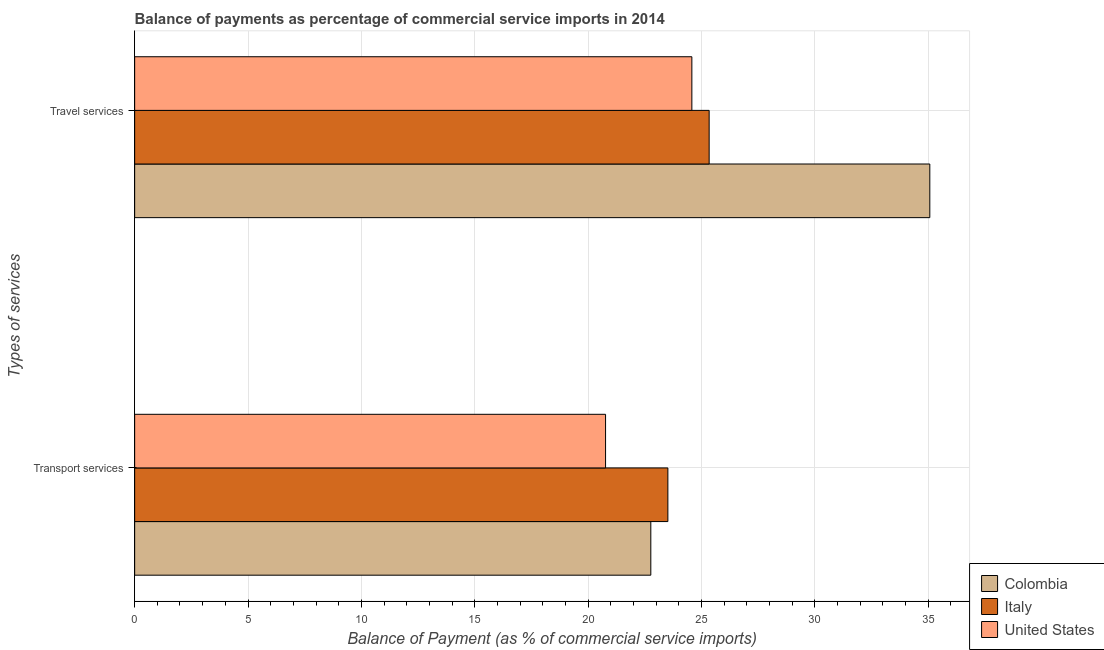How many different coloured bars are there?
Your response must be concise. 3. Are the number of bars on each tick of the Y-axis equal?
Give a very brief answer. Yes. What is the label of the 1st group of bars from the top?
Your answer should be very brief. Travel services. What is the balance of payments of transport services in United States?
Ensure brevity in your answer.  20.77. Across all countries, what is the maximum balance of payments of transport services?
Your answer should be very brief. 23.52. Across all countries, what is the minimum balance of payments of travel services?
Offer a terse response. 24.58. In which country was the balance of payments of travel services maximum?
Offer a very short reply. Colombia. What is the total balance of payments of travel services in the graph?
Your answer should be compact. 85. What is the difference between the balance of payments of transport services in United States and that in Colombia?
Offer a terse response. -2. What is the difference between the balance of payments of travel services in Italy and the balance of payments of transport services in United States?
Provide a succinct answer. 4.57. What is the average balance of payments of transport services per country?
Keep it short and to the point. 22.35. What is the difference between the balance of payments of travel services and balance of payments of transport services in Italy?
Provide a succinct answer. 1.82. What is the ratio of the balance of payments of transport services in United States to that in Italy?
Offer a terse response. 0.88. Is the balance of payments of transport services in United States less than that in Colombia?
Provide a succinct answer. Yes. What does the 1st bar from the top in Transport services represents?
Your answer should be compact. United States. What does the 3rd bar from the bottom in Transport services represents?
Your answer should be compact. United States. How many bars are there?
Offer a terse response. 6. Are all the bars in the graph horizontal?
Your answer should be compact. Yes. What is the difference between two consecutive major ticks on the X-axis?
Keep it short and to the point. 5. Does the graph contain grids?
Ensure brevity in your answer.  Yes. How are the legend labels stacked?
Provide a short and direct response. Vertical. What is the title of the graph?
Offer a terse response. Balance of payments as percentage of commercial service imports in 2014. Does "Nepal" appear as one of the legend labels in the graph?
Give a very brief answer. No. What is the label or title of the X-axis?
Your response must be concise. Balance of Payment (as % of commercial service imports). What is the label or title of the Y-axis?
Make the answer very short. Types of services. What is the Balance of Payment (as % of commercial service imports) in Colombia in Transport services?
Offer a terse response. 22.77. What is the Balance of Payment (as % of commercial service imports) in Italy in Transport services?
Make the answer very short. 23.52. What is the Balance of Payment (as % of commercial service imports) of United States in Transport services?
Ensure brevity in your answer.  20.77. What is the Balance of Payment (as % of commercial service imports) of Colombia in Travel services?
Your answer should be compact. 35.08. What is the Balance of Payment (as % of commercial service imports) of Italy in Travel services?
Provide a succinct answer. 25.34. What is the Balance of Payment (as % of commercial service imports) in United States in Travel services?
Make the answer very short. 24.58. Across all Types of services, what is the maximum Balance of Payment (as % of commercial service imports) in Colombia?
Offer a terse response. 35.08. Across all Types of services, what is the maximum Balance of Payment (as % of commercial service imports) in Italy?
Provide a succinct answer. 25.34. Across all Types of services, what is the maximum Balance of Payment (as % of commercial service imports) of United States?
Offer a very short reply. 24.58. Across all Types of services, what is the minimum Balance of Payment (as % of commercial service imports) in Colombia?
Give a very brief answer. 22.77. Across all Types of services, what is the minimum Balance of Payment (as % of commercial service imports) in Italy?
Make the answer very short. 23.52. Across all Types of services, what is the minimum Balance of Payment (as % of commercial service imports) of United States?
Give a very brief answer. 20.77. What is the total Balance of Payment (as % of commercial service imports) in Colombia in the graph?
Make the answer very short. 57.84. What is the total Balance of Payment (as % of commercial service imports) of Italy in the graph?
Keep it short and to the point. 48.86. What is the total Balance of Payment (as % of commercial service imports) of United States in the graph?
Keep it short and to the point. 45.35. What is the difference between the Balance of Payment (as % of commercial service imports) in Colombia in Transport services and that in Travel services?
Give a very brief answer. -12.31. What is the difference between the Balance of Payment (as % of commercial service imports) of Italy in Transport services and that in Travel services?
Ensure brevity in your answer.  -1.82. What is the difference between the Balance of Payment (as % of commercial service imports) of United States in Transport services and that in Travel services?
Provide a short and direct response. -3.81. What is the difference between the Balance of Payment (as % of commercial service imports) in Colombia in Transport services and the Balance of Payment (as % of commercial service imports) in Italy in Travel services?
Give a very brief answer. -2.57. What is the difference between the Balance of Payment (as % of commercial service imports) of Colombia in Transport services and the Balance of Payment (as % of commercial service imports) of United States in Travel services?
Give a very brief answer. -1.81. What is the difference between the Balance of Payment (as % of commercial service imports) of Italy in Transport services and the Balance of Payment (as % of commercial service imports) of United States in Travel services?
Your answer should be compact. -1.06. What is the average Balance of Payment (as % of commercial service imports) of Colombia per Types of services?
Make the answer very short. 28.92. What is the average Balance of Payment (as % of commercial service imports) of Italy per Types of services?
Your response must be concise. 24.43. What is the average Balance of Payment (as % of commercial service imports) of United States per Types of services?
Ensure brevity in your answer.  22.68. What is the difference between the Balance of Payment (as % of commercial service imports) in Colombia and Balance of Payment (as % of commercial service imports) in Italy in Transport services?
Make the answer very short. -0.75. What is the difference between the Balance of Payment (as % of commercial service imports) in Colombia and Balance of Payment (as % of commercial service imports) in United States in Transport services?
Provide a short and direct response. 2. What is the difference between the Balance of Payment (as % of commercial service imports) of Italy and Balance of Payment (as % of commercial service imports) of United States in Transport services?
Make the answer very short. 2.75. What is the difference between the Balance of Payment (as % of commercial service imports) of Colombia and Balance of Payment (as % of commercial service imports) of Italy in Travel services?
Keep it short and to the point. 9.73. What is the difference between the Balance of Payment (as % of commercial service imports) in Colombia and Balance of Payment (as % of commercial service imports) in United States in Travel services?
Your answer should be compact. 10.5. What is the difference between the Balance of Payment (as % of commercial service imports) in Italy and Balance of Payment (as % of commercial service imports) in United States in Travel services?
Offer a terse response. 0.76. What is the ratio of the Balance of Payment (as % of commercial service imports) of Colombia in Transport services to that in Travel services?
Offer a terse response. 0.65. What is the ratio of the Balance of Payment (as % of commercial service imports) of Italy in Transport services to that in Travel services?
Your answer should be compact. 0.93. What is the ratio of the Balance of Payment (as % of commercial service imports) of United States in Transport services to that in Travel services?
Keep it short and to the point. 0.85. What is the difference between the highest and the second highest Balance of Payment (as % of commercial service imports) in Colombia?
Your answer should be compact. 12.31. What is the difference between the highest and the second highest Balance of Payment (as % of commercial service imports) in Italy?
Make the answer very short. 1.82. What is the difference between the highest and the second highest Balance of Payment (as % of commercial service imports) in United States?
Your answer should be very brief. 3.81. What is the difference between the highest and the lowest Balance of Payment (as % of commercial service imports) of Colombia?
Offer a very short reply. 12.31. What is the difference between the highest and the lowest Balance of Payment (as % of commercial service imports) in Italy?
Provide a short and direct response. 1.82. What is the difference between the highest and the lowest Balance of Payment (as % of commercial service imports) in United States?
Give a very brief answer. 3.81. 